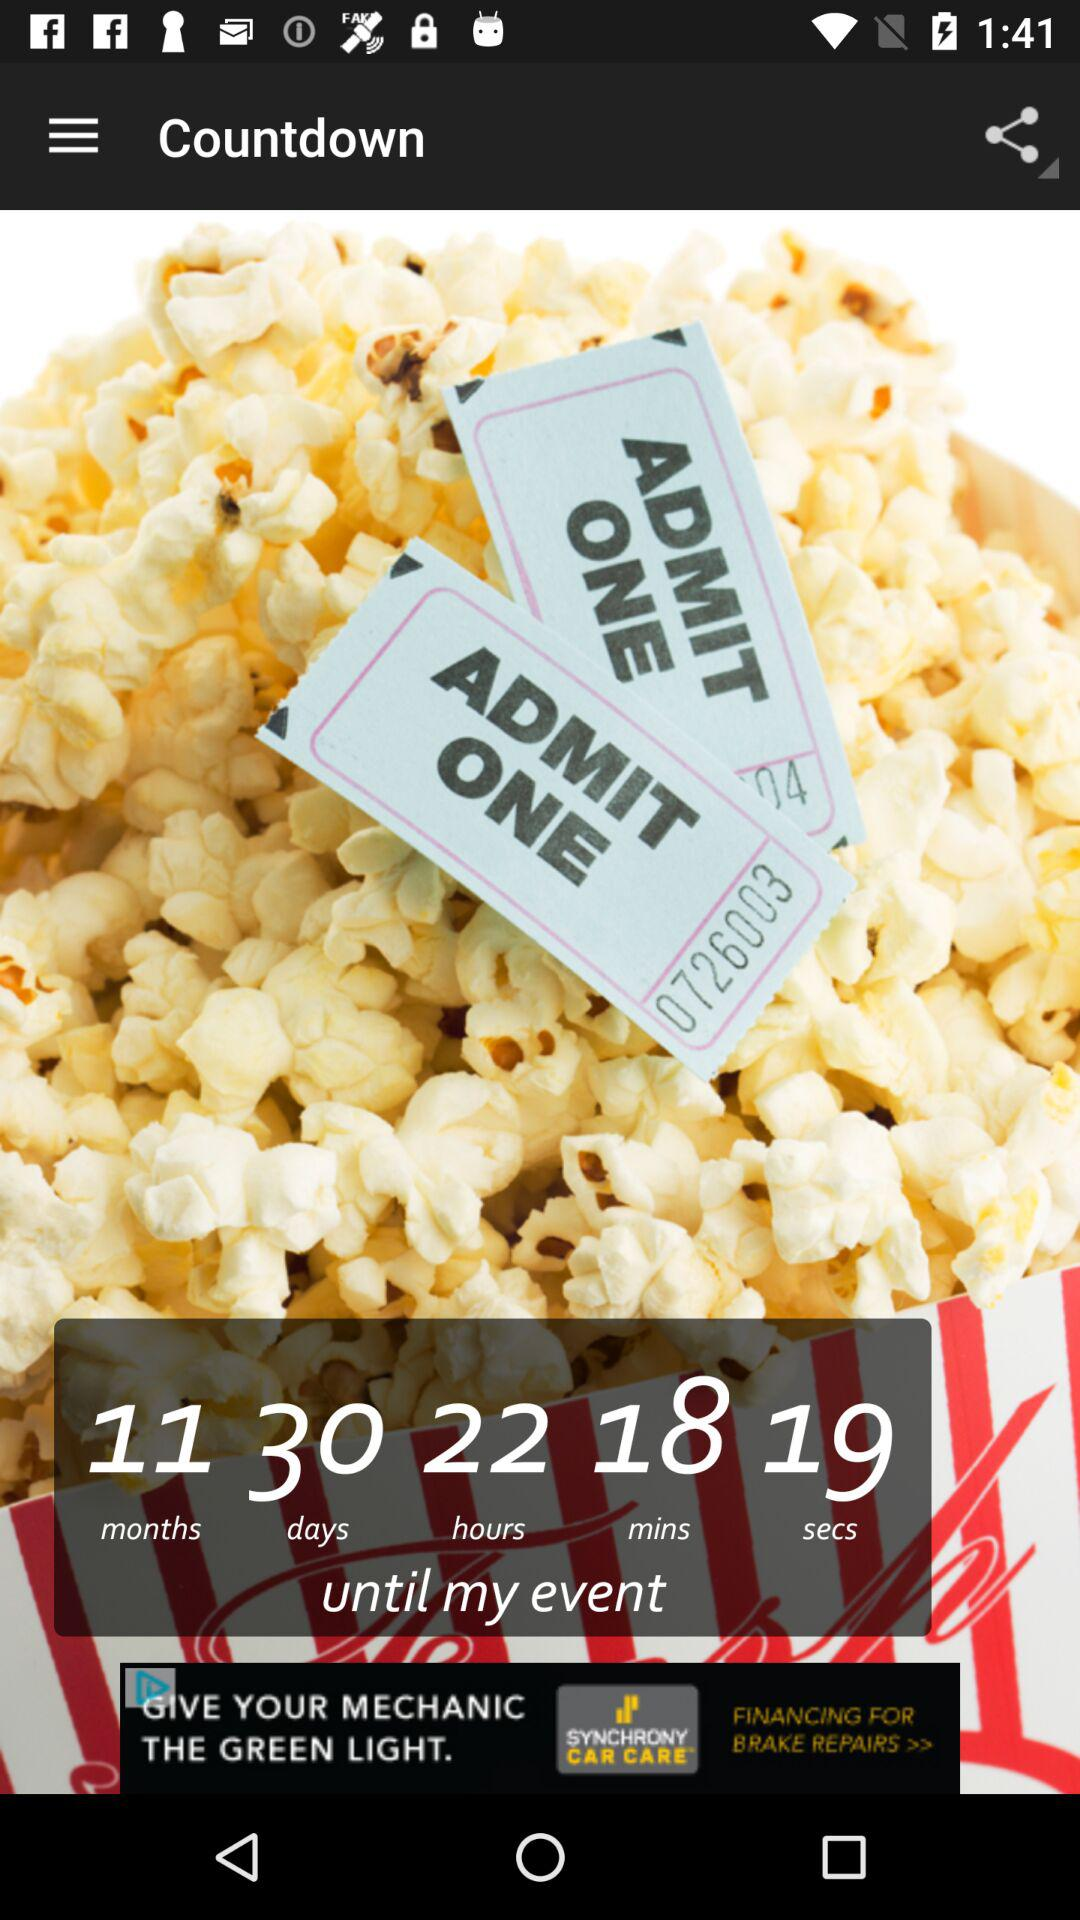What is the remaining time for the event to take place? The remaining time for the event to take place is 11 months, 30 days, 22 hours, 18 minutes, and 19 seconds. 